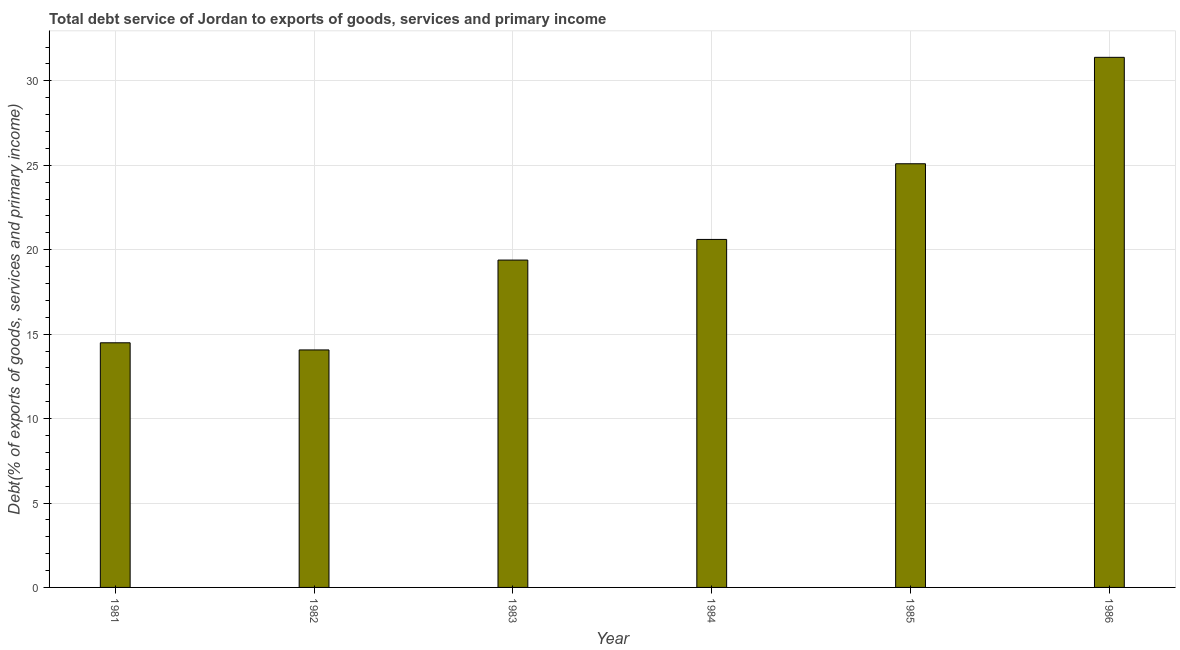What is the title of the graph?
Keep it short and to the point. Total debt service of Jordan to exports of goods, services and primary income. What is the label or title of the Y-axis?
Give a very brief answer. Debt(% of exports of goods, services and primary income). What is the total debt service in 1986?
Your answer should be very brief. 31.39. Across all years, what is the maximum total debt service?
Provide a succinct answer. 31.39. Across all years, what is the minimum total debt service?
Ensure brevity in your answer.  14.07. In which year was the total debt service minimum?
Keep it short and to the point. 1982. What is the sum of the total debt service?
Your response must be concise. 125.04. What is the difference between the total debt service in 1982 and 1984?
Provide a succinct answer. -6.54. What is the average total debt service per year?
Make the answer very short. 20.84. What is the median total debt service?
Keep it short and to the point. 20. What is the ratio of the total debt service in 1982 to that in 1985?
Give a very brief answer. 0.56. What is the difference between the highest and the second highest total debt service?
Offer a very short reply. 6.3. What is the difference between the highest and the lowest total debt service?
Give a very brief answer. 17.33. How many years are there in the graph?
Make the answer very short. 6. What is the difference between two consecutive major ticks on the Y-axis?
Offer a very short reply. 5. Are the values on the major ticks of Y-axis written in scientific E-notation?
Offer a terse response. No. What is the Debt(% of exports of goods, services and primary income) of 1981?
Give a very brief answer. 14.49. What is the Debt(% of exports of goods, services and primary income) of 1982?
Ensure brevity in your answer.  14.07. What is the Debt(% of exports of goods, services and primary income) in 1983?
Offer a terse response. 19.39. What is the Debt(% of exports of goods, services and primary income) of 1984?
Provide a short and direct response. 20.61. What is the Debt(% of exports of goods, services and primary income) of 1985?
Keep it short and to the point. 25.09. What is the Debt(% of exports of goods, services and primary income) in 1986?
Your response must be concise. 31.39. What is the difference between the Debt(% of exports of goods, services and primary income) in 1981 and 1982?
Give a very brief answer. 0.42. What is the difference between the Debt(% of exports of goods, services and primary income) in 1981 and 1983?
Keep it short and to the point. -4.9. What is the difference between the Debt(% of exports of goods, services and primary income) in 1981 and 1984?
Give a very brief answer. -6.12. What is the difference between the Debt(% of exports of goods, services and primary income) in 1981 and 1985?
Offer a very short reply. -10.6. What is the difference between the Debt(% of exports of goods, services and primary income) in 1981 and 1986?
Make the answer very short. -16.91. What is the difference between the Debt(% of exports of goods, services and primary income) in 1982 and 1983?
Offer a very short reply. -5.32. What is the difference between the Debt(% of exports of goods, services and primary income) in 1982 and 1984?
Your answer should be very brief. -6.54. What is the difference between the Debt(% of exports of goods, services and primary income) in 1982 and 1985?
Offer a very short reply. -11.03. What is the difference between the Debt(% of exports of goods, services and primary income) in 1982 and 1986?
Your answer should be compact. -17.33. What is the difference between the Debt(% of exports of goods, services and primary income) in 1983 and 1984?
Your answer should be compact. -1.22. What is the difference between the Debt(% of exports of goods, services and primary income) in 1983 and 1985?
Offer a terse response. -5.7. What is the difference between the Debt(% of exports of goods, services and primary income) in 1983 and 1986?
Provide a short and direct response. -12.01. What is the difference between the Debt(% of exports of goods, services and primary income) in 1984 and 1985?
Provide a succinct answer. -4.48. What is the difference between the Debt(% of exports of goods, services and primary income) in 1984 and 1986?
Provide a succinct answer. -10.78. What is the difference between the Debt(% of exports of goods, services and primary income) in 1985 and 1986?
Give a very brief answer. -6.3. What is the ratio of the Debt(% of exports of goods, services and primary income) in 1981 to that in 1982?
Your answer should be very brief. 1.03. What is the ratio of the Debt(% of exports of goods, services and primary income) in 1981 to that in 1983?
Offer a terse response. 0.75. What is the ratio of the Debt(% of exports of goods, services and primary income) in 1981 to that in 1984?
Provide a short and direct response. 0.7. What is the ratio of the Debt(% of exports of goods, services and primary income) in 1981 to that in 1985?
Make the answer very short. 0.58. What is the ratio of the Debt(% of exports of goods, services and primary income) in 1981 to that in 1986?
Make the answer very short. 0.46. What is the ratio of the Debt(% of exports of goods, services and primary income) in 1982 to that in 1983?
Keep it short and to the point. 0.72. What is the ratio of the Debt(% of exports of goods, services and primary income) in 1982 to that in 1984?
Keep it short and to the point. 0.68. What is the ratio of the Debt(% of exports of goods, services and primary income) in 1982 to that in 1985?
Make the answer very short. 0.56. What is the ratio of the Debt(% of exports of goods, services and primary income) in 1982 to that in 1986?
Offer a very short reply. 0.45. What is the ratio of the Debt(% of exports of goods, services and primary income) in 1983 to that in 1984?
Keep it short and to the point. 0.94. What is the ratio of the Debt(% of exports of goods, services and primary income) in 1983 to that in 1985?
Your response must be concise. 0.77. What is the ratio of the Debt(% of exports of goods, services and primary income) in 1983 to that in 1986?
Offer a terse response. 0.62. What is the ratio of the Debt(% of exports of goods, services and primary income) in 1984 to that in 1985?
Your answer should be very brief. 0.82. What is the ratio of the Debt(% of exports of goods, services and primary income) in 1984 to that in 1986?
Offer a terse response. 0.66. What is the ratio of the Debt(% of exports of goods, services and primary income) in 1985 to that in 1986?
Ensure brevity in your answer.  0.8. 